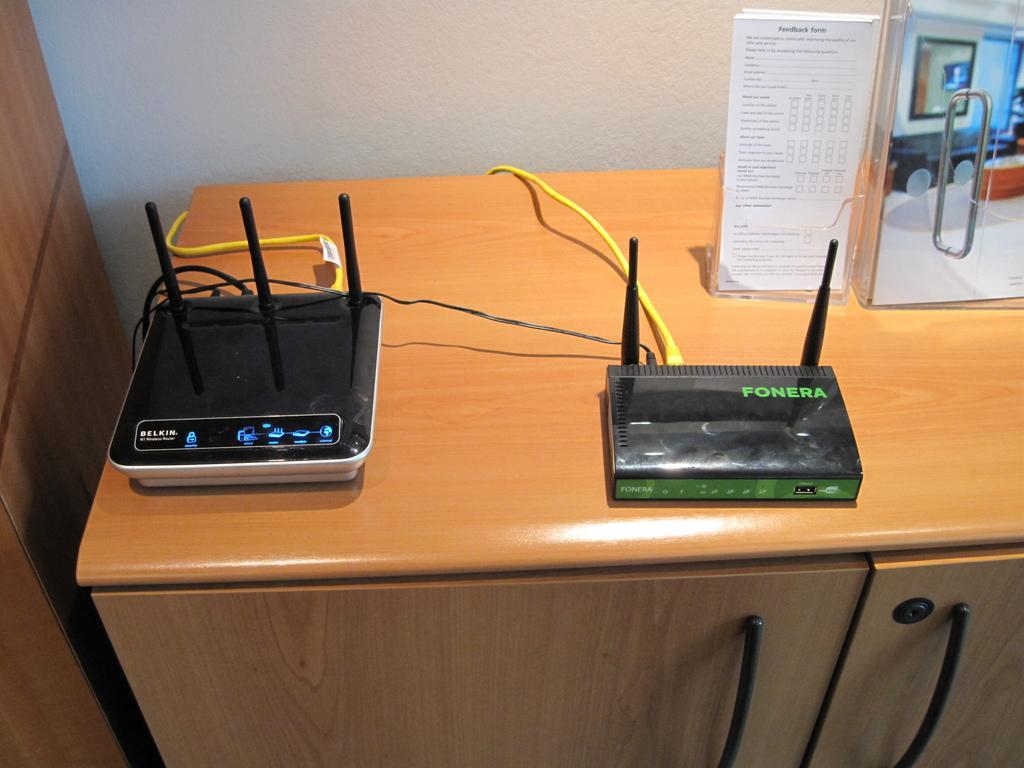Describe this image in one or two sentences. In this image there is a table on which there are two WiFi routers with the wires. On the right side there is a glass door on the table. At the bottom there is a cupboard. There are few papers kept in the plastic stand on the table. 